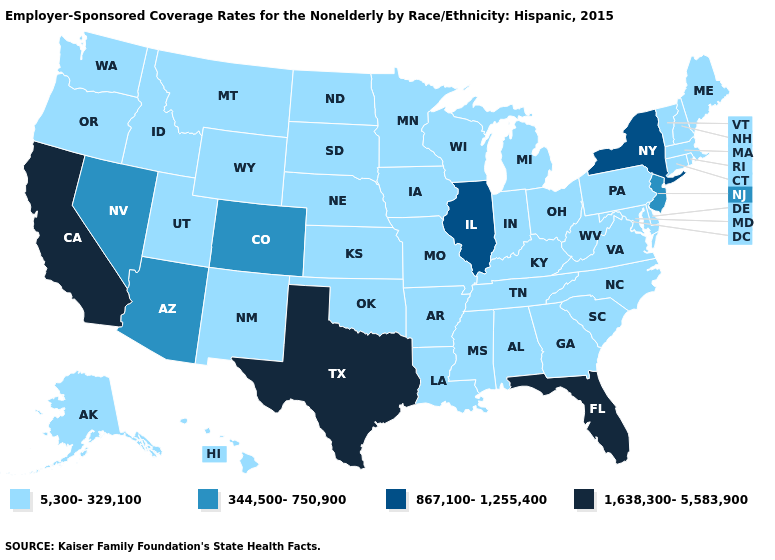Name the states that have a value in the range 5,300-329,100?
Short answer required. Alabama, Alaska, Arkansas, Connecticut, Delaware, Georgia, Hawaii, Idaho, Indiana, Iowa, Kansas, Kentucky, Louisiana, Maine, Maryland, Massachusetts, Michigan, Minnesota, Mississippi, Missouri, Montana, Nebraska, New Hampshire, New Mexico, North Carolina, North Dakota, Ohio, Oklahoma, Oregon, Pennsylvania, Rhode Island, South Carolina, South Dakota, Tennessee, Utah, Vermont, Virginia, Washington, West Virginia, Wisconsin, Wyoming. Name the states that have a value in the range 1,638,300-5,583,900?
Concise answer only. California, Florida, Texas. Does the map have missing data?
Keep it brief. No. Is the legend a continuous bar?
Be succinct. No. What is the lowest value in the South?
Write a very short answer. 5,300-329,100. Does Michigan have a lower value than New Jersey?
Give a very brief answer. Yes. Among the states that border Maryland , which have the highest value?
Write a very short answer. Delaware, Pennsylvania, Virginia, West Virginia. Name the states that have a value in the range 867,100-1,255,400?
Write a very short answer. Illinois, New York. Name the states that have a value in the range 1,638,300-5,583,900?
Write a very short answer. California, Florida, Texas. Among the states that border Florida , which have the lowest value?
Write a very short answer. Alabama, Georgia. What is the value of North Dakota?
Answer briefly. 5,300-329,100. What is the highest value in states that border Texas?
Give a very brief answer. 5,300-329,100. Among the states that border Virginia , which have the highest value?
Be succinct. Kentucky, Maryland, North Carolina, Tennessee, West Virginia. What is the highest value in the MidWest ?
Concise answer only. 867,100-1,255,400. Name the states that have a value in the range 1,638,300-5,583,900?
Write a very short answer. California, Florida, Texas. 